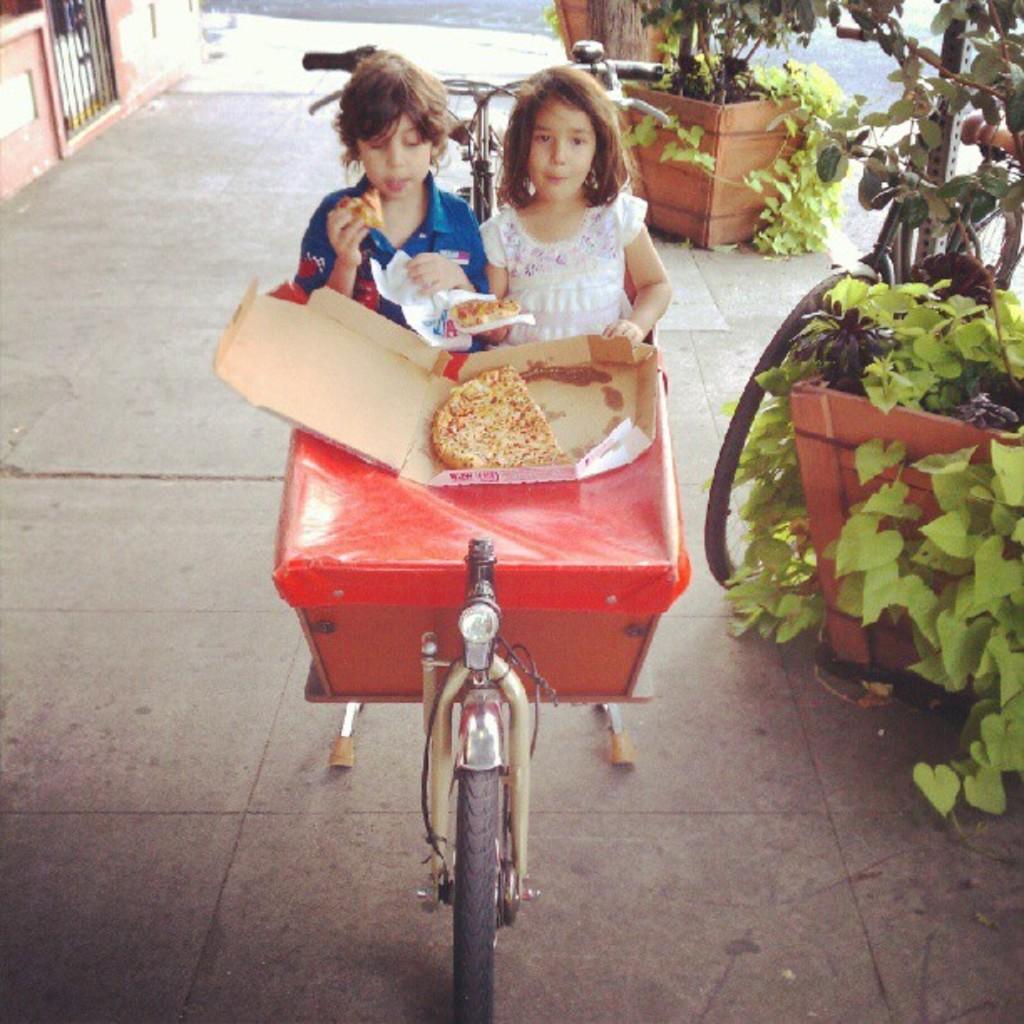Please provide a concise description of this image. In this image there is a path, on that path there are cycles, on that cycle, there is a box, on that box there is a pizza two kids are eating the pizza, on the right side there are plants, bicycle. 